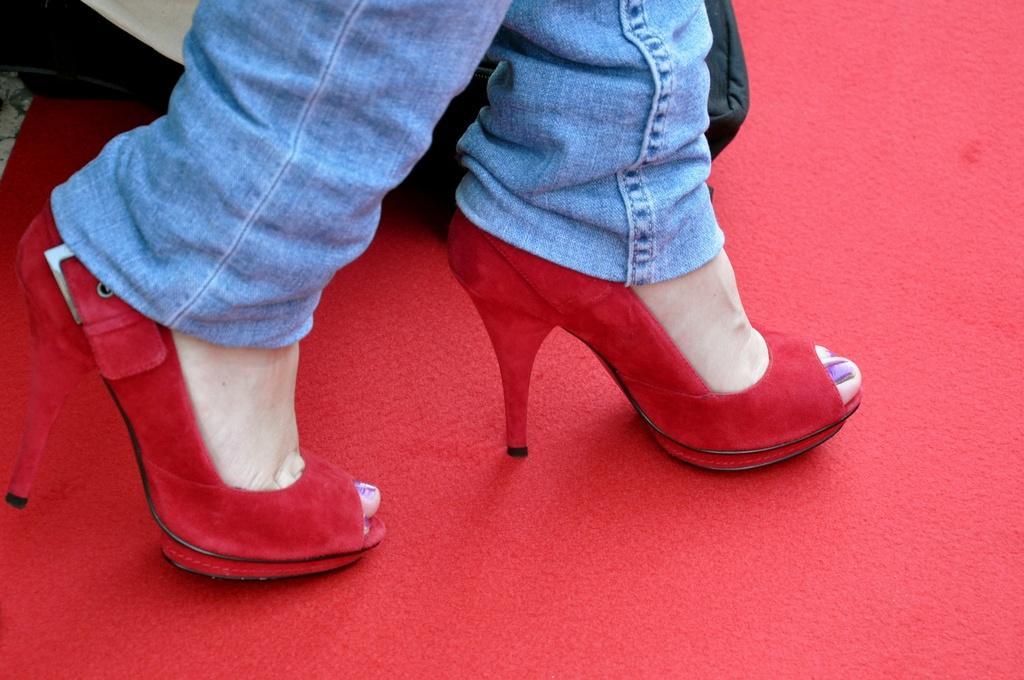How would you summarize this image in a sentence or two? In the center of this picture we can see the legs of a person wearing trousers and red color heels and walking on the red color carpet. In the background we can see an object placed on the ground. 